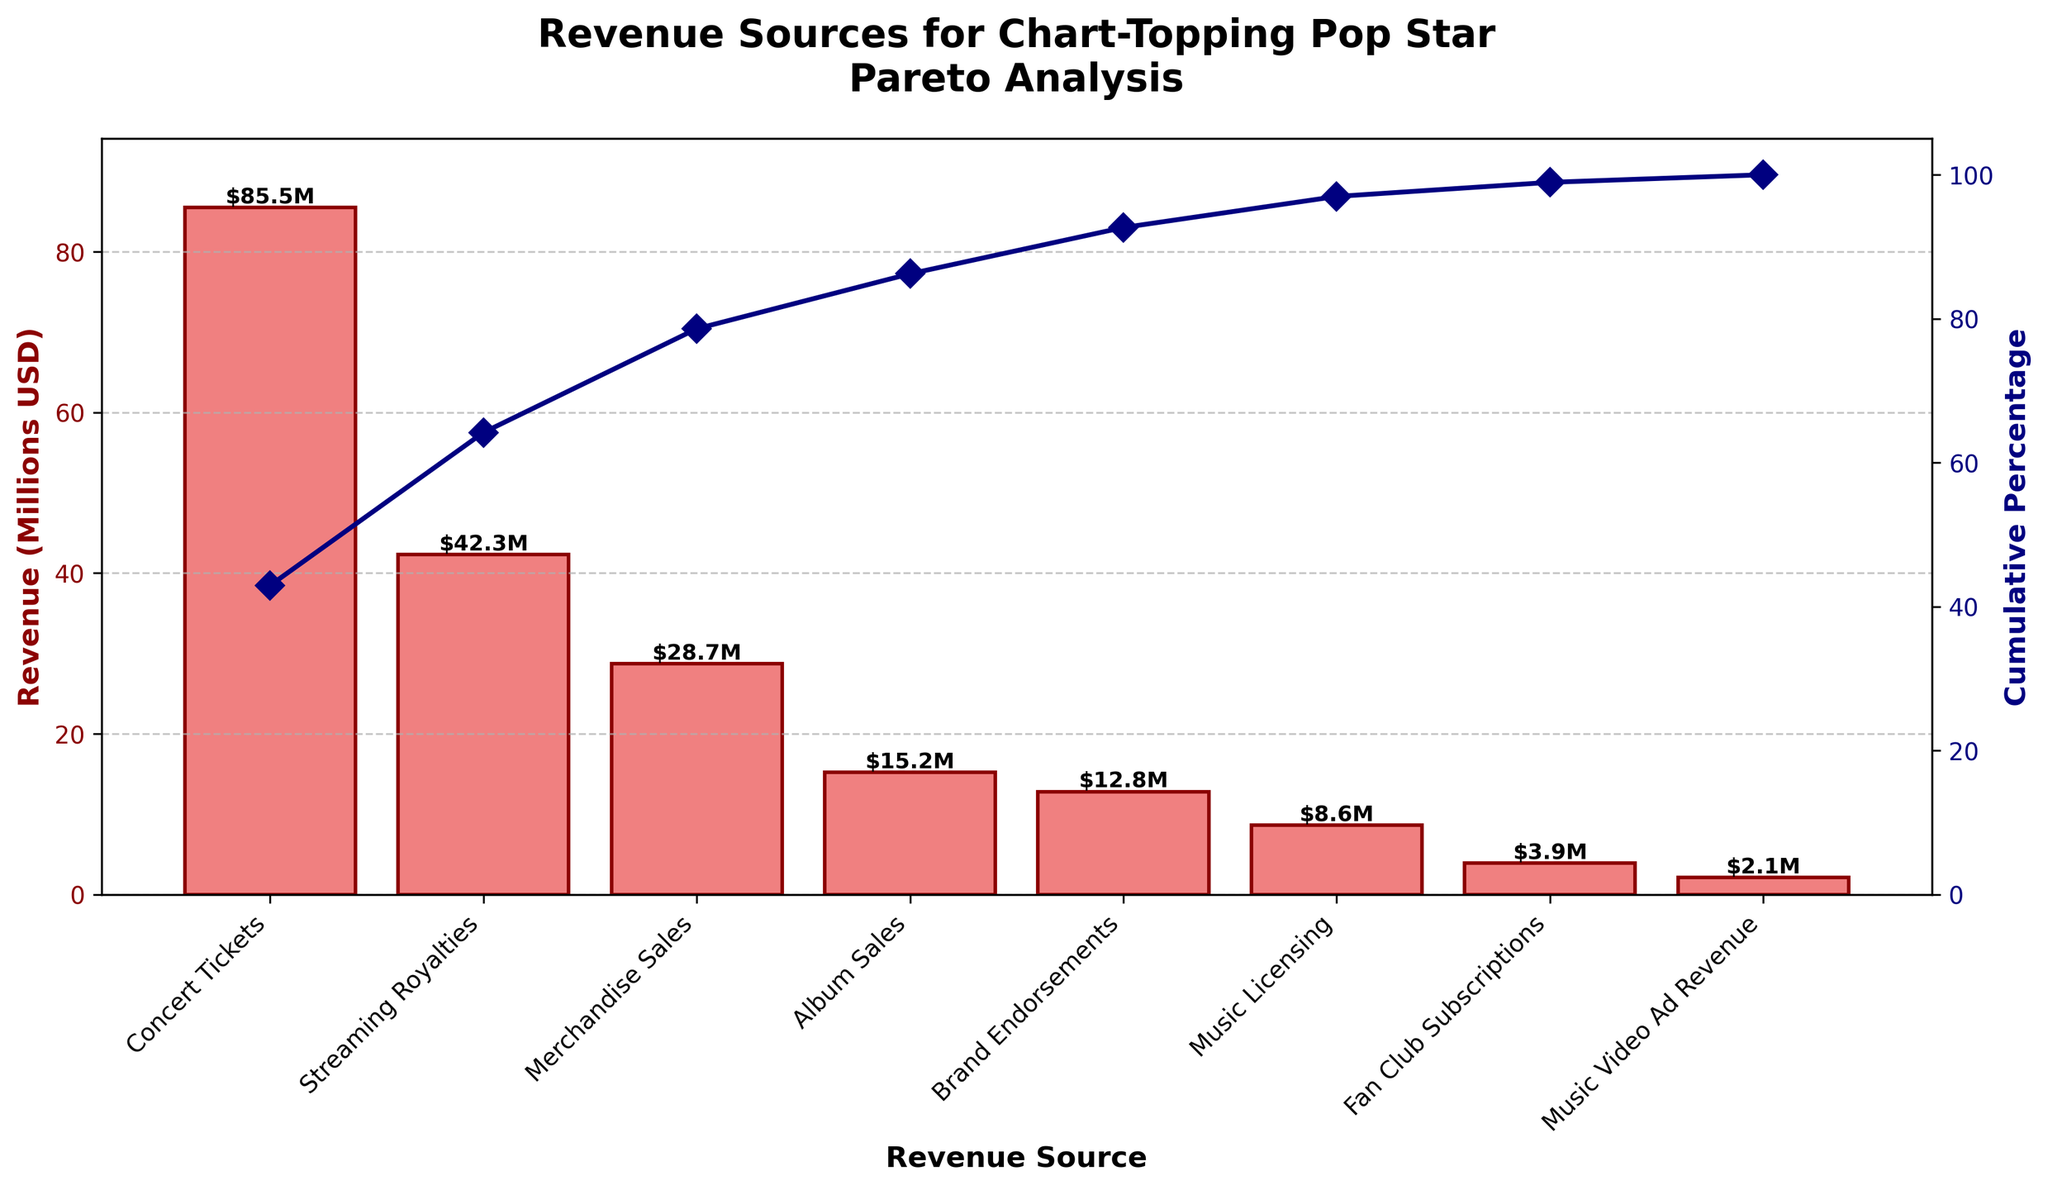What is the title of the plot? Look at the top of the figure where the title is usually placed. The title provides a summary of what the chart represents.
Answer: "Revenue Sources for Chart-Topping Pop Star\nPareto Analysis" How many revenue sources are shown in the bar graph? Count the distinct bars on the x-axis of the figure. Each bar represents a different revenue source.
Answer: 8 Which revenue source contributes the most to the total revenue? Examine the height of the bars; the tallest bar represents the revenue source contributing the most.
Answer: Concert Tickets What is the cumulative percentage after considering "Merchandise Sales"? Find "Merchandise Sales" on the x-axis and look at the corresponding data point in the cumulative percentage line, identified by the marker.
Answer: Approximately 87% What is the range of revenue amounts shown on the y-axis for the bar chart? Look at the lowest and highest values marked on the y-axis for revenue. This captures the span from the smallest to the largest amount.
Answer: 0 to 100 million USD (approximated) Is the revenue from "Brand Endorsements" higher or lower than "Album Sales"? Compare the heights of the bars labeled "Brand Endorsements" and "Album Sales". The taller bar has the higher value.
Answer: Lower What color are the bars representing revenue amounts? Look at the bars on the chart to identify their color.
Answer: Light Coral What is the total revenue generated from all sources combined? To find this, identify the maximum value of the "Cumulative Percentage" line which should be 100%, then look at that corresponding revenue amount on the left y-axis (considering approximations).
Answer: Approximately 200 million USD (total revenue sum) How does the height of the "Fan Club Subscriptions" bar compare to the "Music Licensing" bar? Compare these two bars directly; since "Music Licensing" is higher up the y-axis, it is taller.
Answer: Lower At which revenue source does the cumulative percentage exceed 90%? Follow the cumulative percentage line until it crosses the 90% mark, then check the corresponding x-axis label.
Answer: Brand Endorsements 